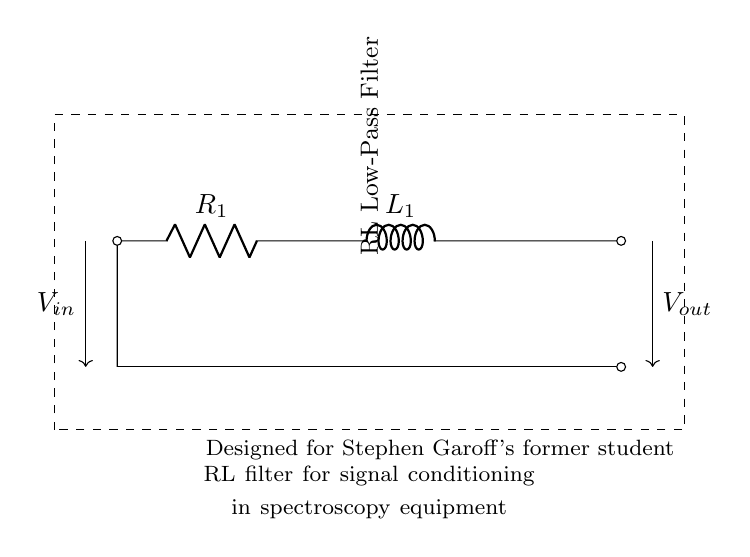What does the circuit represent? The circuit represents an RL Low-Pass Filter used for signal conditioning in spectroscopy equipment. This is indicated by the label in the diagram.
Answer: RL Low-Pass Filter What components are present in this circuit? The circuit includes a resistor labeled R1 and an inductor labeled L1, which are typical components of an RL filter. The labels next to the components provide this identification.
Answer: Resistor and Inductor What is the input voltage of the circuit? The input voltage is represented by V_in, indicated by the arrow pointing into the circuit from the left side. The diagram shows where the voltage enters the circuit.
Answer: V_in What is the output of the circuit? The output of the circuit is represented by V_out, as indicated by the arrow pointing out of the circuit on the right side. This signifies the voltage that exits the circuit.
Answer: V_out How does the current flow in this circuit? The current flows from left to right, starting at V_in, through R1, then L1, and finally exiting at V_out. This is inferred from the direction of the arrows in the diagram indicating current flow.
Answer: Left to right What is the main function of this RL circuit in spectroscopy? The main function of this RL circuit is to act as a Low-Pass Filter, allowing low-frequency signals to pass while attenuating high-frequency noise. This is a fundamental characteristic of RL filters used for signal conditioning.
Answer: Low-Pass Filter What type of filtering characteristic does this circuit provide? This circuit provides a low-pass filtering characteristic, which means it allows signals with frequencies lower than a certain cutoff frequency to pass while attenuating higher frequencies. This is intrinsic to the design of RL filters.
Answer: Low-pass filtering 